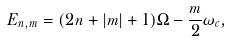<formula> <loc_0><loc_0><loc_500><loc_500>E _ { n , m } = ( 2 n + | m | + 1 ) \Omega - \frac { m } { 2 } \omega _ { c } ,</formula> 